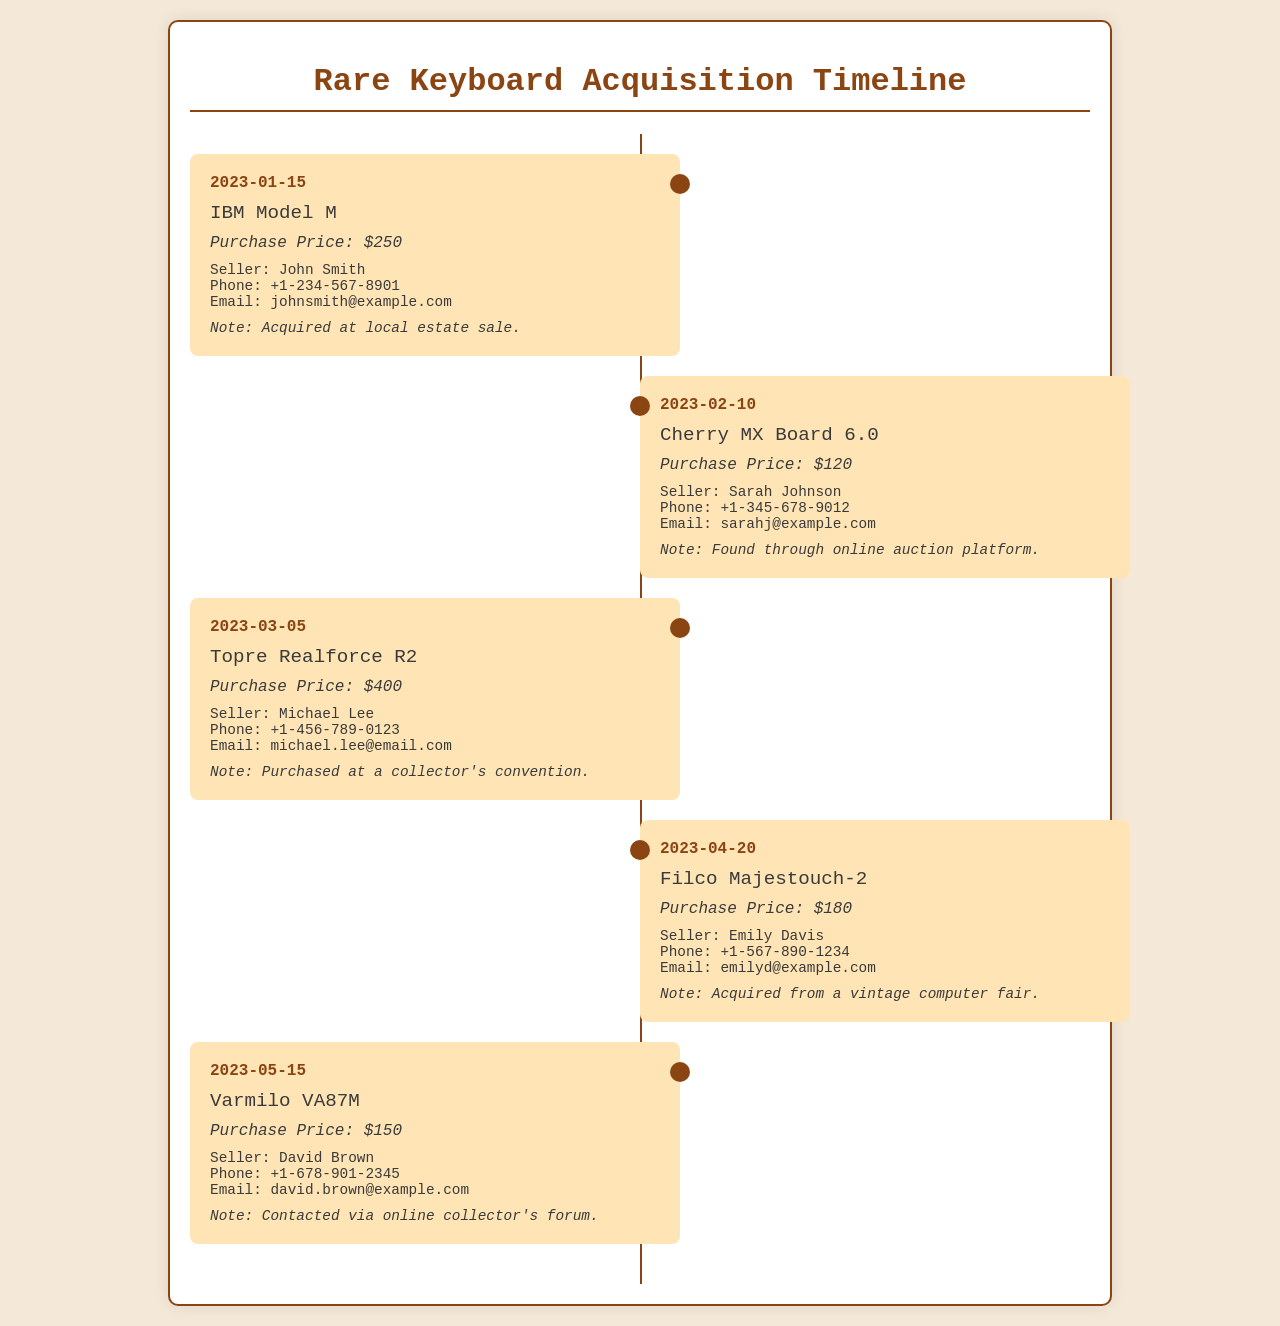What is the acquisition date of the IBM Model M? The acquisition date can be found in the document; it is listed as January 15, 2023.
Answer: 2023-01-15 Who is the seller for the Cherry MX Board 6.0? The seller's name is mentioned in the section detailing the keyboard acquisition; it states Sarah Johnson.
Answer: Sarah Johnson What was the purchase price of the Topre Realforce R2? The document specifies the purchase price directly in the entry for this keyboard, which is $400.
Answer: $400 When was the Filco Majestouch-2 acquired? The date of acquisition is provided in the document and is April 20, 2023.
Answer: 2023-04-20 Which keyboard was acquired from a vintage computer fair? The document notes that the Filco Majestouch-2 was obtained from a vintage computer fair.
Answer: Filco Majestouch-2 How many keyboards were acquired in total? The total number of entries for keyboards gives a count of the items listed in the document; there are five keyboards.
Answer: 5 What contact information is provided for David Brown? The document includes a contact entry showing his phone number and email address; the phone number is +1-678-901-2345.
Answer: +1-678-901-2345 What type of event was the Topre Realforce R2 purchased at? The document mentions that it was purchased at a collector's convention, which indicates the kind of event.
Answer: Collector's convention Which keyboard had the lowest purchase price? The purchase prices are compared in the entries, which shows the Cherry MX Board 6.0 at $120 as the lowest price.
Answer: $120 